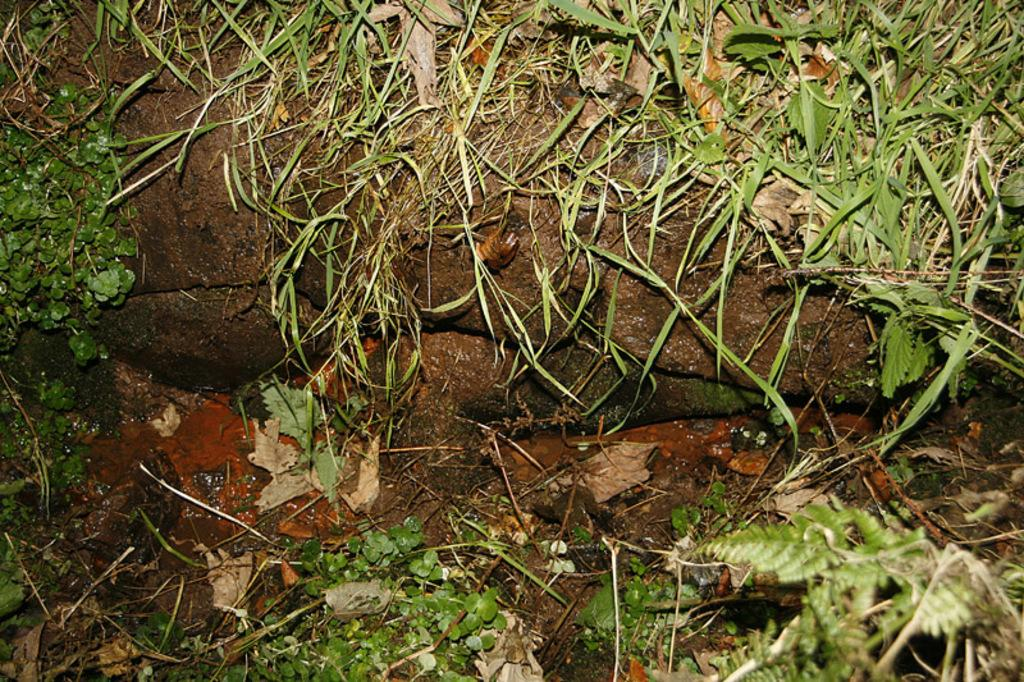What type of structure can be seen in the image? There is a wall in the image. Can you describe the condition of the wall? The wall appears to be wet. What type of vegetation is visible in the image? There is green grass visible in the image. What other plant-related elements can be seen in the image? Leaves and tiny plants are present in the image. What type of muscle is being exercised by the wall in the image? There is no muscle present in the image, as the wall is an inanimate object. 